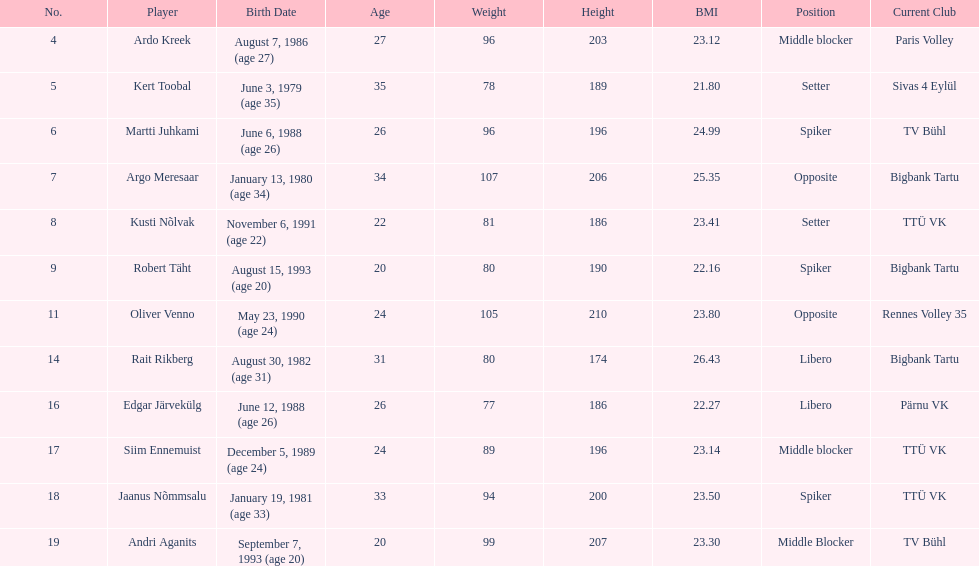Which player is taller than andri agantis? Oliver Venno. 